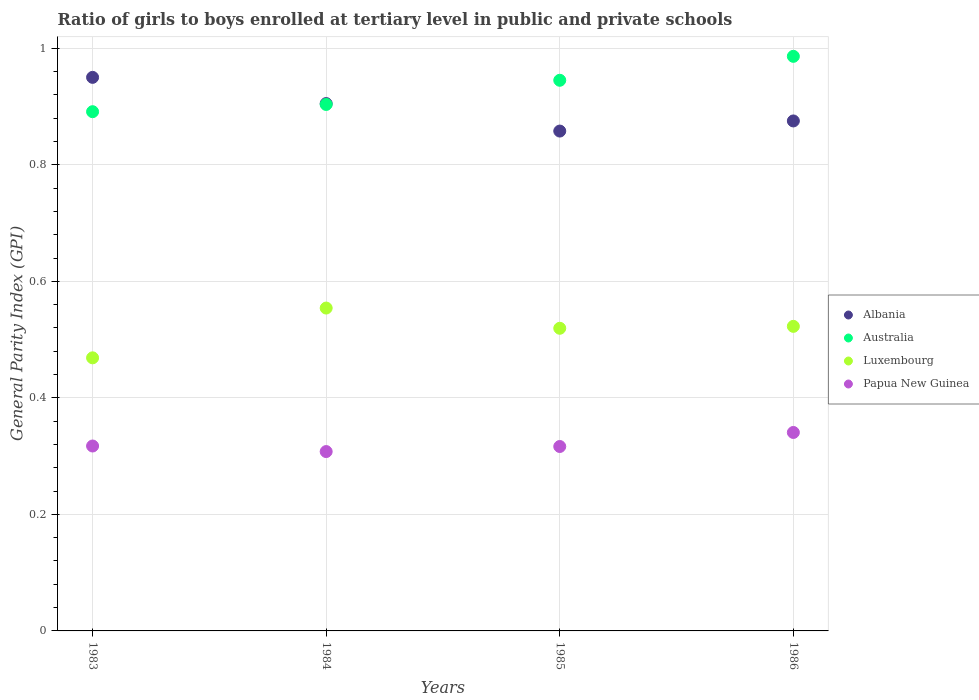What is the general parity index in Albania in 1986?
Provide a succinct answer. 0.88. Across all years, what is the maximum general parity index in Australia?
Offer a very short reply. 0.99. Across all years, what is the minimum general parity index in Papua New Guinea?
Keep it short and to the point. 0.31. In which year was the general parity index in Albania maximum?
Provide a succinct answer. 1983. In which year was the general parity index in Albania minimum?
Give a very brief answer. 1985. What is the total general parity index in Luxembourg in the graph?
Your answer should be compact. 2.06. What is the difference between the general parity index in Luxembourg in 1984 and that in 1985?
Keep it short and to the point. 0.03. What is the difference between the general parity index in Luxembourg in 1984 and the general parity index in Australia in 1985?
Your answer should be very brief. -0.39. What is the average general parity index in Luxembourg per year?
Give a very brief answer. 0.52. In the year 1985, what is the difference between the general parity index in Luxembourg and general parity index in Albania?
Make the answer very short. -0.34. In how many years, is the general parity index in Papua New Guinea greater than 0.6400000000000001?
Offer a terse response. 0. What is the ratio of the general parity index in Papua New Guinea in 1985 to that in 1986?
Your response must be concise. 0.93. Is the general parity index in Albania in 1984 less than that in 1985?
Your answer should be compact. No. Is the difference between the general parity index in Luxembourg in 1984 and 1986 greater than the difference between the general parity index in Albania in 1984 and 1986?
Offer a terse response. Yes. What is the difference between the highest and the second highest general parity index in Australia?
Your answer should be compact. 0.04. What is the difference between the highest and the lowest general parity index in Luxembourg?
Provide a short and direct response. 0.09. In how many years, is the general parity index in Papua New Guinea greater than the average general parity index in Papua New Guinea taken over all years?
Offer a very short reply. 1. Does the general parity index in Australia monotonically increase over the years?
Provide a short and direct response. Yes. Is the general parity index in Australia strictly less than the general parity index in Luxembourg over the years?
Your response must be concise. No. Are the values on the major ticks of Y-axis written in scientific E-notation?
Make the answer very short. No. Does the graph contain grids?
Ensure brevity in your answer.  Yes. How are the legend labels stacked?
Your answer should be very brief. Vertical. What is the title of the graph?
Your answer should be very brief. Ratio of girls to boys enrolled at tertiary level in public and private schools. What is the label or title of the Y-axis?
Offer a very short reply. General Parity Index (GPI). What is the General Parity Index (GPI) in Albania in 1983?
Your response must be concise. 0.95. What is the General Parity Index (GPI) in Australia in 1983?
Your answer should be compact. 0.89. What is the General Parity Index (GPI) in Luxembourg in 1983?
Keep it short and to the point. 0.47. What is the General Parity Index (GPI) of Papua New Guinea in 1983?
Your response must be concise. 0.32. What is the General Parity Index (GPI) of Albania in 1984?
Ensure brevity in your answer.  0.91. What is the General Parity Index (GPI) in Australia in 1984?
Make the answer very short. 0.9. What is the General Parity Index (GPI) in Luxembourg in 1984?
Your answer should be very brief. 0.55. What is the General Parity Index (GPI) in Papua New Guinea in 1984?
Offer a very short reply. 0.31. What is the General Parity Index (GPI) of Albania in 1985?
Offer a very short reply. 0.86. What is the General Parity Index (GPI) in Australia in 1985?
Make the answer very short. 0.95. What is the General Parity Index (GPI) of Luxembourg in 1985?
Offer a very short reply. 0.52. What is the General Parity Index (GPI) in Papua New Guinea in 1985?
Provide a succinct answer. 0.32. What is the General Parity Index (GPI) in Albania in 1986?
Give a very brief answer. 0.88. What is the General Parity Index (GPI) of Australia in 1986?
Make the answer very short. 0.99. What is the General Parity Index (GPI) in Luxembourg in 1986?
Offer a terse response. 0.52. What is the General Parity Index (GPI) of Papua New Guinea in 1986?
Your answer should be compact. 0.34. Across all years, what is the maximum General Parity Index (GPI) of Albania?
Your answer should be very brief. 0.95. Across all years, what is the maximum General Parity Index (GPI) in Australia?
Give a very brief answer. 0.99. Across all years, what is the maximum General Parity Index (GPI) of Luxembourg?
Make the answer very short. 0.55. Across all years, what is the maximum General Parity Index (GPI) in Papua New Guinea?
Your response must be concise. 0.34. Across all years, what is the minimum General Parity Index (GPI) of Albania?
Give a very brief answer. 0.86. Across all years, what is the minimum General Parity Index (GPI) in Australia?
Ensure brevity in your answer.  0.89. Across all years, what is the minimum General Parity Index (GPI) of Luxembourg?
Provide a succinct answer. 0.47. Across all years, what is the minimum General Parity Index (GPI) in Papua New Guinea?
Offer a very short reply. 0.31. What is the total General Parity Index (GPI) of Albania in the graph?
Keep it short and to the point. 3.59. What is the total General Parity Index (GPI) in Australia in the graph?
Keep it short and to the point. 3.73. What is the total General Parity Index (GPI) in Luxembourg in the graph?
Provide a succinct answer. 2.06. What is the total General Parity Index (GPI) of Papua New Guinea in the graph?
Give a very brief answer. 1.28. What is the difference between the General Parity Index (GPI) in Albania in 1983 and that in 1984?
Your response must be concise. 0.04. What is the difference between the General Parity Index (GPI) of Australia in 1983 and that in 1984?
Provide a succinct answer. -0.01. What is the difference between the General Parity Index (GPI) of Luxembourg in 1983 and that in 1984?
Offer a terse response. -0.09. What is the difference between the General Parity Index (GPI) in Papua New Guinea in 1983 and that in 1984?
Make the answer very short. 0.01. What is the difference between the General Parity Index (GPI) of Albania in 1983 and that in 1985?
Your response must be concise. 0.09. What is the difference between the General Parity Index (GPI) in Australia in 1983 and that in 1985?
Your answer should be very brief. -0.05. What is the difference between the General Parity Index (GPI) in Luxembourg in 1983 and that in 1985?
Your response must be concise. -0.05. What is the difference between the General Parity Index (GPI) in Papua New Guinea in 1983 and that in 1985?
Make the answer very short. 0. What is the difference between the General Parity Index (GPI) of Albania in 1983 and that in 1986?
Offer a terse response. 0.07. What is the difference between the General Parity Index (GPI) of Australia in 1983 and that in 1986?
Offer a very short reply. -0.1. What is the difference between the General Parity Index (GPI) in Luxembourg in 1983 and that in 1986?
Your answer should be compact. -0.05. What is the difference between the General Parity Index (GPI) of Papua New Guinea in 1983 and that in 1986?
Ensure brevity in your answer.  -0.02. What is the difference between the General Parity Index (GPI) in Albania in 1984 and that in 1985?
Your response must be concise. 0.05. What is the difference between the General Parity Index (GPI) of Australia in 1984 and that in 1985?
Provide a succinct answer. -0.04. What is the difference between the General Parity Index (GPI) of Luxembourg in 1984 and that in 1985?
Keep it short and to the point. 0.03. What is the difference between the General Parity Index (GPI) in Papua New Guinea in 1984 and that in 1985?
Ensure brevity in your answer.  -0.01. What is the difference between the General Parity Index (GPI) in Albania in 1984 and that in 1986?
Give a very brief answer. 0.03. What is the difference between the General Parity Index (GPI) of Australia in 1984 and that in 1986?
Make the answer very short. -0.08. What is the difference between the General Parity Index (GPI) of Luxembourg in 1984 and that in 1986?
Offer a terse response. 0.03. What is the difference between the General Parity Index (GPI) of Papua New Guinea in 1984 and that in 1986?
Make the answer very short. -0.03. What is the difference between the General Parity Index (GPI) of Albania in 1985 and that in 1986?
Keep it short and to the point. -0.02. What is the difference between the General Parity Index (GPI) in Australia in 1985 and that in 1986?
Make the answer very short. -0.04. What is the difference between the General Parity Index (GPI) in Luxembourg in 1985 and that in 1986?
Give a very brief answer. -0. What is the difference between the General Parity Index (GPI) of Papua New Guinea in 1985 and that in 1986?
Provide a short and direct response. -0.02. What is the difference between the General Parity Index (GPI) of Albania in 1983 and the General Parity Index (GPI) of Australia in 1984?
Your answer should be very brief. 0.05. What is the difference between the General Parity Index (GPI) in Albania in 1983 and the General Parity Index (GPI) in Luxembourg in 1984?
Ensure brevity in your answer.  0.4. What is the difference between the General Parity Index (GPI) in Albania in 1983 and the General Parity Index (GPI) in Papua New Guinea in 1984?
Keep it short and to the point. 0.64. What is the difference between the General Parity Index (GPI) of Australia in 1983 and the General Parity Index (GPI) of Luxembourg in 1984?
Give a very brief answer. 0.34. What is the difference between the General Parity Index (GPI) of Australia in 1983 and the General Parity Index (GPI) of Papua New Guinea in 1984?
Make the answer very short. 0.58. What is the difference between the General Parity Index (GPI) in Luxembourg in 1983 and the General Parity Index (GPI) in Papua New Guinea in 1984?
Give a very brief answer. 0.16. What is the difference between the General Parity Index (GPI) of Albania in 1983 and the General Parity Index (GPI) of Australia in 1985?
Your response must be concise. 0.01. What is the difference between the General Parity Index (GPI) in Albania in 1983 and the General Parity Index (GPI) in Luxembourg in 1985?
Your response must be concise. 0.43. What is the difference between the General Parity Index (GPI) in Albania in 1983 and the General Parity Index (GPI) in Papua New Guinea in 1985?
Your answer should be compact. 0.63. What is the difference between the General Parity Index (GPI) in Australia in 1983 and the General Parity Index (GPI) in Luxembourg in 1985?
Give a very brief answer. 0.37. What is the difference between the General Parity Index (GPI) in Australia in 1983 and the General Parity Index (GPI) in Papua New Guinea in 1985?
Provide a short and direct response. 0.57. What is the difference between the General Parity Index (GPI) in Luxembourg in 1983 and the General Parity Index (GPI) in Papua New Guinea in 1985?
Provide a short and direct response. 0.15. What is the difference between the General Parity Index (GPI) in Albania in 1983 and the General Parity Index (GPI) in Australia in 1986?
Offer a terse response. -0.04. What is the difference between the General Parity Index (GPI) in Albania in 1983 and the General Parity Index (GPI) in Luxembourg in 1986?
Provide a short and direct response. 0.43. What is the difference between the General Parity Index (GPI) in Albania in 1983 and the General Parity Index (GPI) in Papua New Guinea in 1986?
Your response must be concise. 0.61. What is the difference between the General Parity Index (GPI) of Australia in 1983 and the General Parity Index (GPI) of Luxembourg in 1986?
Offer a terse response. 0.37. What is the difference between the General Parity Index (GPI) of Australia in 1983 and the General Parity Index (GPI) of Papua New Guinea in 1986?
Ensure brevity in your answer.  0.55. What is the difference between the General Parity Index (GPI) in Luxembourg in 1983 and the General Parity Index (GPI) in Papua New Guinea in 1986?
Your response must be concise. 0.13. What is the difference between the General Parity Index (GPI) of Albania in 1984 and the General Parity Index (GPI) of Australia in 1985?
Provide a succinct answer. -0.04. What is the difference between the General Parity Index (GPI) in Albania in 1984 and the General Parity Index (GPI) in Luxembourg in 1985?
Keep it short and to the point. 0.39. What is the difference between the General Parity Index (GPI) in Albania in 1984 and the General Parity Index (GPI) in Papua New Guinea in 1985?
Offer a very short reply. 0.59. What is the difference between the General Parity Index (GPI) in Australia in 1984 and the General Parity Index (GPI) in Luxembourg in 1985?
Your answer should be very brief. 0.38. What is the difference between the General Parity Index (GPI) in Australia in 1984 and the General Parity Index (GPI) in Papua New Guinea in 1985?
Make the answer very short. 0.59. What is the difference between the General Parity Index (GPI) of Luxembourg in 1984 and the General Parity Index (GPI) of Papua New Guinea in 1985?
Your answer should be very brief. 0.24. What is the difference between the General Parity Index (GPI) in Albania in 1984 and the General Parity Index (GPI) in Australia in 1986?
Your response must be concise. -0.08. What is the difference between the General Parity Index (GPI) in Albania in 1984 and the General Parity Index (GPI) in Luxembourg in 1986?
Ensure brevity in your answer.  0.38. What is the difference between the General Parity Index (GPI) in Albania in 1984 and the General Parity Index (GPI) in Papua New Guinea in 1986?
Make the answer very short. 0.56. What is the difference between the General Parity Index (GPI) of Australia in 1984 and the General Parity Index (GPI) of Luxembourg in 1986?
Your answer should be very brief. 0.38. What is the difference between the General Parity Index (GPI) in Australia in 1984 and the General Parity Index (GPI) in Papua New Guinea in 1986?
Make the answer very short. 0.56. What is the difference between the General Parity Index (GPI) in Luxembourg in 1984 and the General Parity Index (GPI) in Papua New Guinea in 1986?
Provide a succinct answer. 0.21. What is the difference between the General Parity Index (GPI) of Albania in 1985 and the General Parity Index (GPI) of Australia in 1986?
Provide a succinct answer. -0.13. What is the difference between the General Parity Index (GPI) in Albania in 1985 and the General Parity Index (GPI) in Luxembourg in 1986?
Provide a succinct answer. 0.34. What is the difference between the General Parity Index (GPI) of Albania in 1985 and the General Parity Index (GPI) of Papua New Guinea in 1986?
Your answer should be very brief. 0.52. What is the difference between the General Parity Index (GPI) of Australia in 1985 and the General Parity Index (GPI) of Luxembourg in 1986?
Keep it short and to the point. 0.42. What is the difference between the General Parity Index (GPI) in Australia in 1985 and the General Parity Index (GPI) in Papua New Guinea in 1986?
Provide a succinct answer. 0.6. What is the difference between the General Parity Index (GPI) of Luxembourg in 1985 and the General Parity Index (GPI) of Papua New Guinea in 1986?
Make the answer very short. 0.18. What is the average General Parity Index (GPI) of Albania per year?
Make the answer very short. 0.9. What is the average General Parity Index (GPI) in Australia per year?
Give a very brief answer. 0.93. What is the average General Parity Index (GPI) of Luxembourg per year?
Offer a terse response. 0.52. What is the average General Parity Index (GPI) of Papua New Guinea per year?
Offer a very short reply. 0.32. In the year 1983, what is the difference between the General Parity Index (GPI) in Albania and General Parity Index (GPI) in Australia?
Offer a very short reply. 0.06. In the year 1983, what is the difference between the General Parity Index (GPI) of Albania and General Parity Index (GPI) of Luxembourg?
Ensure brevity in your answer.  0.48. In the year 1983, what is the difference between the General Parity Index (GPI) in Albania and General Parity Index (GPI) in Papua New Guinea?
Offer a very short reply. 0.63. In the year 1983, what is the difference between the General Parity Index (GPI) in Australia and General Parity Index (GPI) in Luxembourg?
Your answer should be very brief. 0.42. In the year 1983, what is the difference between the General Parity Index (GPI) in Australia and General Parity Index (GPI) in Papua New Guinea?
Your answer should be compact. 0.57. In the year 1983, what is the difference between the General Parity Index (GPI) of Luxembourg and General Parity Index (GPI) of Papua New Guinea?
Offer a terse response. 0.15. In the year 1984, what is the difference between the General Parity Index (GPI) of Albania and General Parity Index (GPI) of Australia?
Your response must be concise. 0. In the year 1984, what is the difference between the General Parity Index (GPI) in Albania and General Parity Index (GPI) in Luxembourg?
Provide a short and direct response. 0.35. In the year 1984, what is the difference between the General Parity Index (GPI) in Albania and General Parity Index (GPI) in Papua New Guinea?
Give a very brief answer. 0.6. In the year 1984, what is the difference between the General Parity Index (GPI) in Australia and General Parity Index (GPI) in Luxembourg?
Keep it short and to the point. 0.35. In the year 1984, what is the difference between the General Parity Index (GPI) in Australia and General Parity Index (GPI) in Papua New Guinea?
Your answer should be very brief. 0.6. In the year 1984, what is the difference between the General Parity Index (GPI) in Luxembourg and General Parity Index (GPI) in Papua New Guinea?
Your answer should be compact. 0.25. In the year 1985, what is the difference between the General Parity Index (GPI) of Albania and General Parity Index (GPI) of Australia?
Your response must be concise. -0.09. In the year 1985, what is the difference between the General Parity Index (GPI) in Albania and General Parity Index (GPI) in Luxembourg?
Make the answer very short. 0.34. In the year 1985, what is the difference between the General Parity Index (GPI) in Albania and General Parity Index (GPI) in Papua New Guinea?
Your answer should be very brief. 0.54. In the year 1985, what is the difference between the General Parity Index (GPI) of Australia and General Parity Index (GPI) of Luxembourg?
Your response must be concise. 0.43. In the year 1985, what is the difference between the General Parity Index (GPI) of Australia and General Parity Index (GPI) of Papua New Guinea?
Ensure brevity in your answer.  0.63. In the year 1985, what is the difference between the General Parity Index (GPI) in Luxembourg and General Parity Index (GPI) in Papua New Guinea?
Provide a succinct answer. 0.2. In the year 1986, what is the difference between the General Parity Index (GPI) of Albania and General Parity Index (GPI) of Australia?
Give a very brief answer. -0.11. In the year 1986, what is the difference between the General Parity Index (GPI) in Albania and General Parity Index (GPI) in Luxembourg?
Ensure brevity in your answer.  0.35. In the year 1986, what is the difference between the General Parity Index (GPI) in Albania and General Parity Index (GPI) in Papua New Guinea?
Provide a succinct answer. 0.53. In the year 1986, what is the difference between the General Parity Index (GPI) of Australia and General Parity Index (GPI) of Luxembourg?
Your answer should be compact. 0.46. In the year 1986, what is the difference between the General Parity Index (GPI) in Australia and General Parity Index (GPI) in Papua New Guinea?
Keep it short and to the point. 0.65. In the year 1986, what is the difference between the General Parity Index (GPI) in Luxembourg and General Parity Index (GPI) in Papua New Guinea?
Offer a terse response. 0.18. What is the ratio of the General Parity Index (GPI) in Albania in 1983 to that in 1984?
Provide a succinct answer. 1.05. What is the ratio of the General Parity Index (GPI) of Australia in 1983 to that in 1984?
Make the answer very short. 0.99. What is the ratio of the General Parity Index (GPI) in Luxembourg in 1983 to that in 1984?
Your response must be concise. 0.85. What is the ratio of the General Parity Index (GPI) in Papua New Guinea in 1983 to that in 1984?
Keep it short and to the point. 1.03. What is the ratio of the General Parity Index (GPI) in Albania in 1983 to that in 1985?
Provide a short and direct response. 1.11. What is the ratio of the General Parity Index (GPI) of Australia in 1983 to that in 1985?
Make the answer very short. 0.94. What is the ratio of the General Parity Index (GPI) of Luxembourg in 1983 to that in 1985?
Keep it short and to the point. 0.9. What is the ratio of the General Parity Index (GPI) in Papua New Guinea in 1983 to that in 1985?
Keep it short and to the point. 1. What is the ratio of the General Parity Index (GPI) of Albania in 1983 to that in 1986?
Give a very brief answer. 1.09. What is the ratio of the General Parity Index (GPI) in Australia in 1983 to that in 1986?
Make the answer very short. 0.9. What is the ratio of the General Parity Index (GPI) in Luxembourg in 1983 to that in 1986?
Make the answer very short. 0.9. What is the ratio of the General Parity Index (GPI) in Papua New Guinea in 1983 to that in 1986?
Your answer should be compact. 0.93. What is the ratio of the General Parity Index (GPI) of Albania in 1984 to that in 1985?
Provide a short and direct response. 1.05. What is the ratio of the General Parity Index (GPI) in Australia in 1984 to that in 1985?
Make the answer very short. 0.96. What is the ratio of the General Parity Index (GPI) of Luxembourg in 1984 to that in 1985?
Ensure brevity in your answer.  1.07. What is the ratio of the General Parity Index (GPI) of Papua New Guinea in 1984 to that in 1985?
Make the answer very short. 0.97. What is the ratio of the General Parity Index (GPI) of Albania in 1984 to that in 1986?
Provide a short and direct response. 1.03. What is the ratio of the General Parity Index (GPI) of Australia in 1984 to that in 1986?
Provide a succinct answer. 0.92. What is the ratio of the General Parity Index (GPI) of Luxembourg in 1984 to that in 1986?
Your response must be concise. 1.06. What is the ratio of the General Parity Index (GPI) in Papua New Guinea in 1984 to that in 1986?
Make the answer very short. 0.9. What is the ratio of the General Parity Index (GPI) of Albania in 1985 to that in 1986?
Give a very brief answer. 0.98. What is the ratio of the General Parity Index (GPI) of Australia in 1985 to that in 1986?
Ensure brevity in your answer.  0.96. What is the ratio of the General Parity Index (GPI) in Papua New Guinea in 1985 to that in 1986?
Your response must be concise. 0.93. What is the difference between the highest and the second highest General Parity Index (GPI) of Albania?
Your response must be concise. 0.04. What is the difference between the highest and the second highest General Parity Index (GPI) in Australia?
Make the answer very short. 0.04. What is the difference between the highest and the second highest General Parity Index (GPI) of Luxembourg?
Ensure brevity in your answer.  0.03. What is the difference between the highest and the second highest General Parity Index (GPI) of Papua New Guinea?
Keep it short and to the point. 0.02. What is the difference between the highest and the lowest General Parity Index (GPI) of Albania?
Give a very brief answer. 0.09. What is the difference between the highest and the lowest General Parity Index (GPI) of Australia?
Give a very brief answer. 0.1. What is the difference between the highest and the lowest General Parity Index (GPI) of Luxembourg?
Provide a succinct answer. 0.09. What is the difference between the highest and the lowest General Parity Index (GPI) of Papua New Guinea?
Offer a terse response. 0.03. 